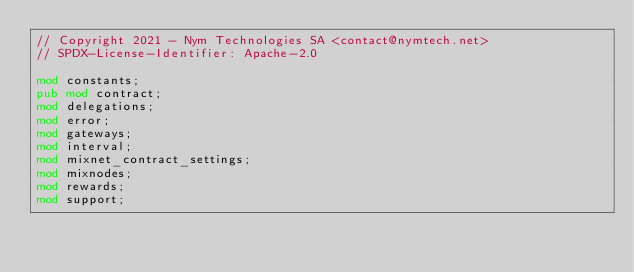Convert code to text. <code><loc_0><loc_0><loc_500><loc_500><_Rust_>// Copyright 2021 - Nym Technologies SA <contact@nymtech.net>
// SPDX-License-Identifier: Apache-2.0

mod constants;
pub mod contract;
mod delegations;
mod error;
mod gateways;
mod interval;
mod mixnet_contract_settings;
mod mixnodes;
mod rewards;
mod support;
</code> 